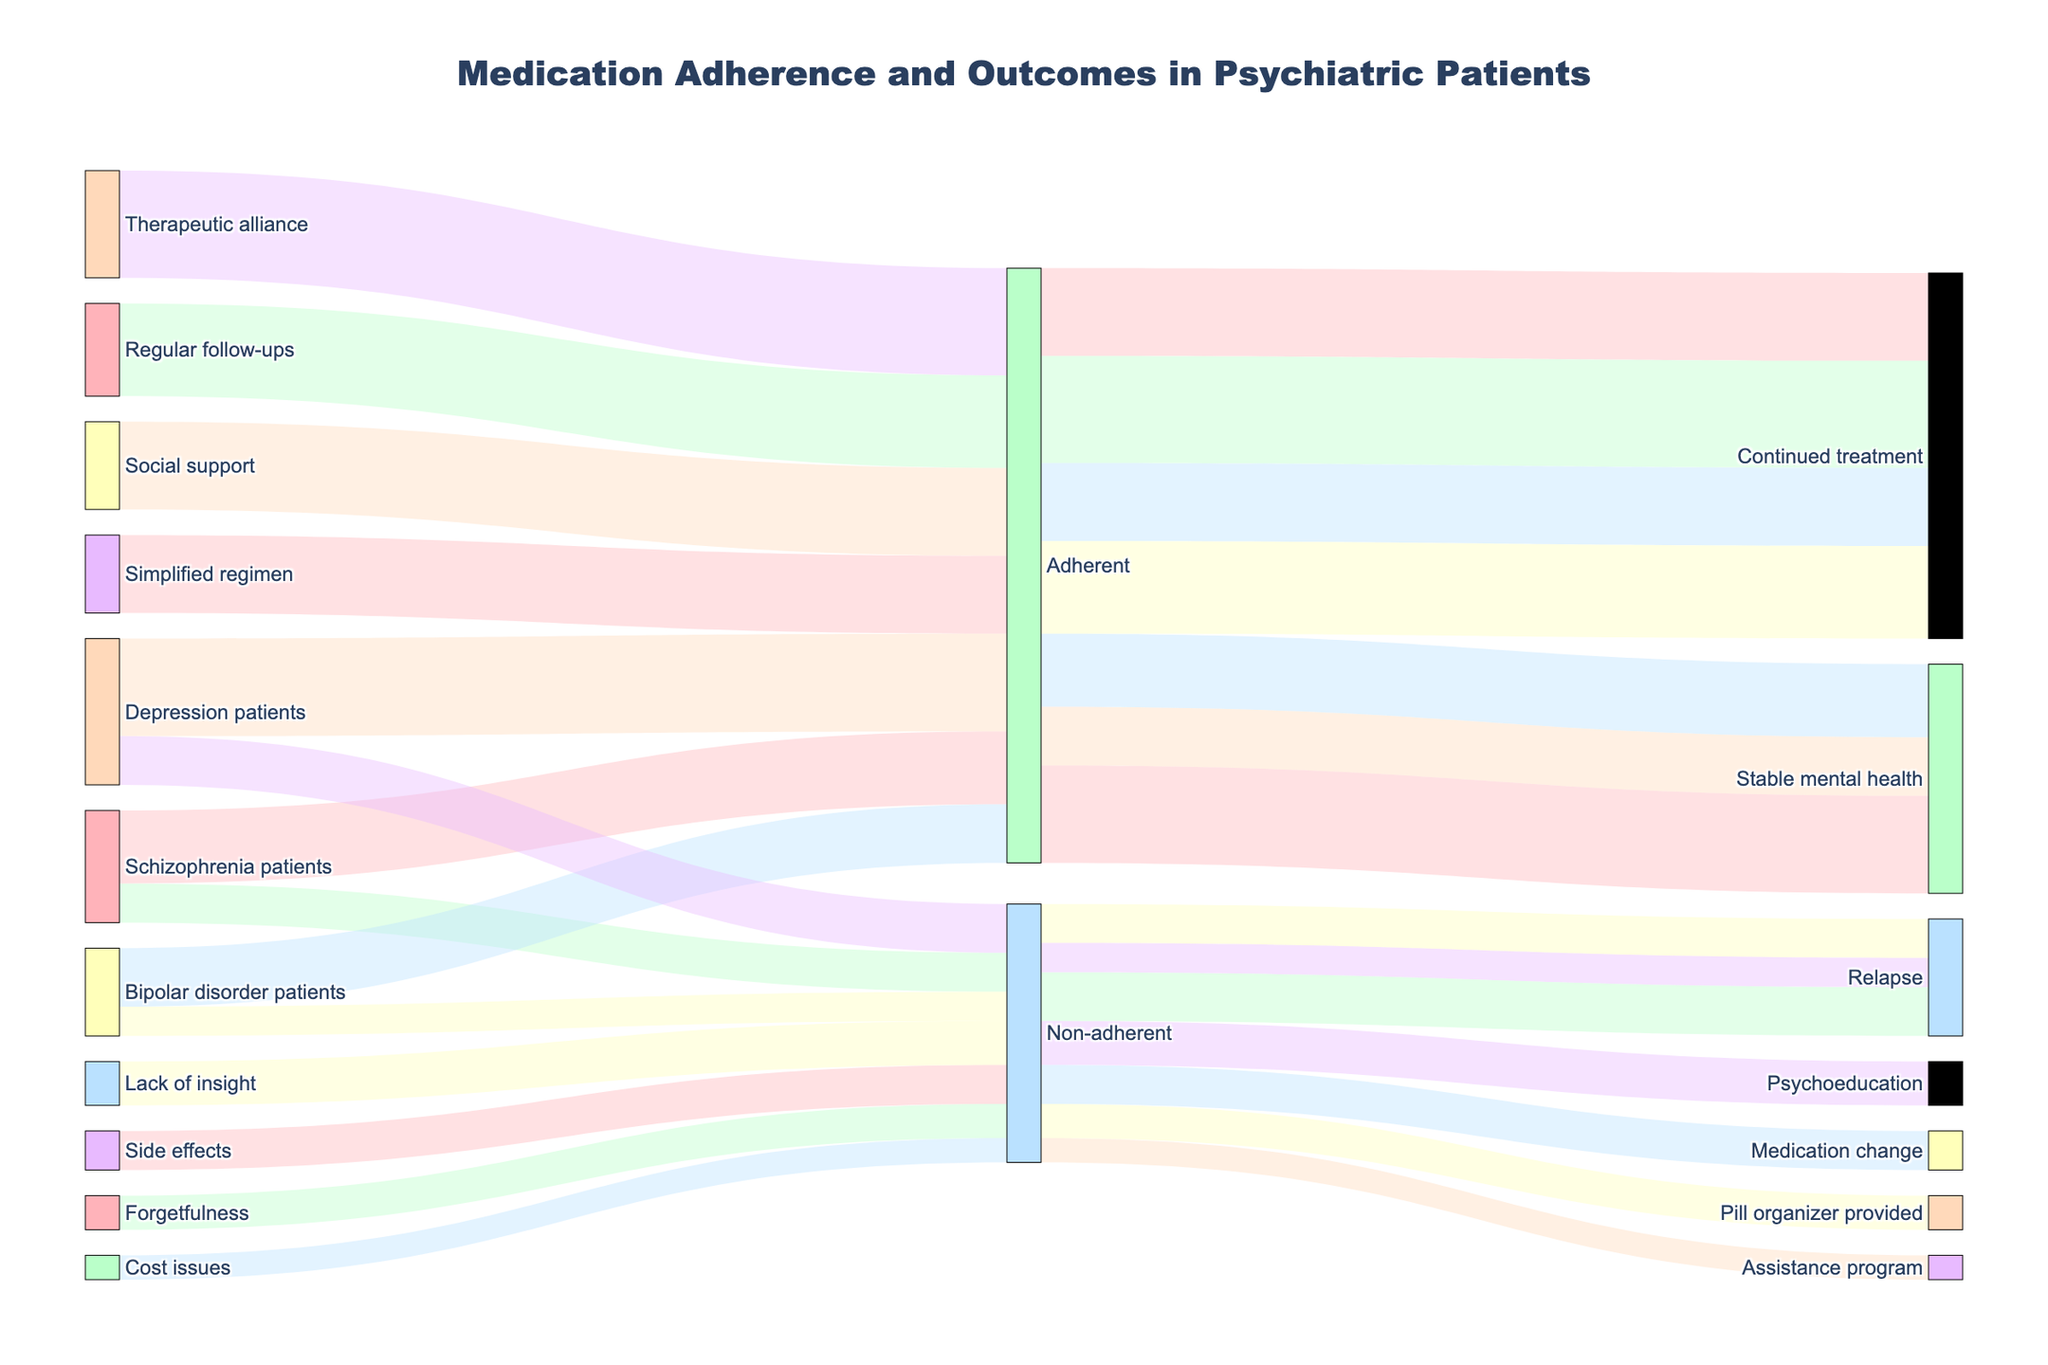What's the title of the diagram? At the top of the diagram, the title can be found which helps to describe the content and context of the figure. This is a basic identification question.
Answer: Medication Adherence and Outcomes in Psychiatric Patients What is the total number of schizophrenia patients included in the diagram? To find this, sum the number of patients who are adherent and non-adherent under the 'Schizophrenia patients' category. Specifically, add 150 (adherent) and 80 (non-adherent).
Answer: 230 How many patients received assistance programs due to cost issues? Check the value associated with the transition from 'Cost issues' to 'Assistance program' in the diagram, which shows the count directly.
Answer: 50 Which adherence status leads to more stable mental health in bipolar disorder patients? Compare the values of bipolar disorder patients who are adherent and those who are non-adherent. Here, 120 (adherent) leads to stable mental health, which is more than the other transitions.
Answer: Adherent What are the various follow-up actions for non-adherent patients, and how many patients correspond to each action? Identify the transitions stemming from 'Non-adherent' to various outcomes: 'Medication change' (80), 'Pill organizer provided' (70), 'Assistance program' (50), and 'Psychoeducation' (90), and sum the targets.
Answer: Medication change: 80, Pill organizer provided: 70, Assistance program: 50, Psychoeducation: 90 How many patients with depression are adherent compared to those who are non-adherent? Compare the numbers under 'Depression patients': 200 (adherent) vs. 100 (non-adherent). The adherent patients are more than the non-adherent patients by a factor of 2 to 1.
Answer: Adherent: 200, Non-adherent: 100 What is the combined number of psychiatric patients who achieve stable mental health as a result of medication adherence? Sum the number of stable outcomes for patients with schizophrenia, bipolar disorder, and depression: 150 + 120 + 200 = 470.
Answer: 470 Which outcome has the highest number of associated patients for non-adherent individuals? Compare all outcomes connected to 'Non-adherent' patients and find the largest number: 'Psychoeducation' has 90 patients.
Answer: Psychoeducation Which adherence support factor contributes the most to continued treatment? Compare the values under 'Adherent' leading to 'Continued treatment': 'Therapeutic alliance' (220) has the highest count compared to others.
Answer: Therapeutic alliance 